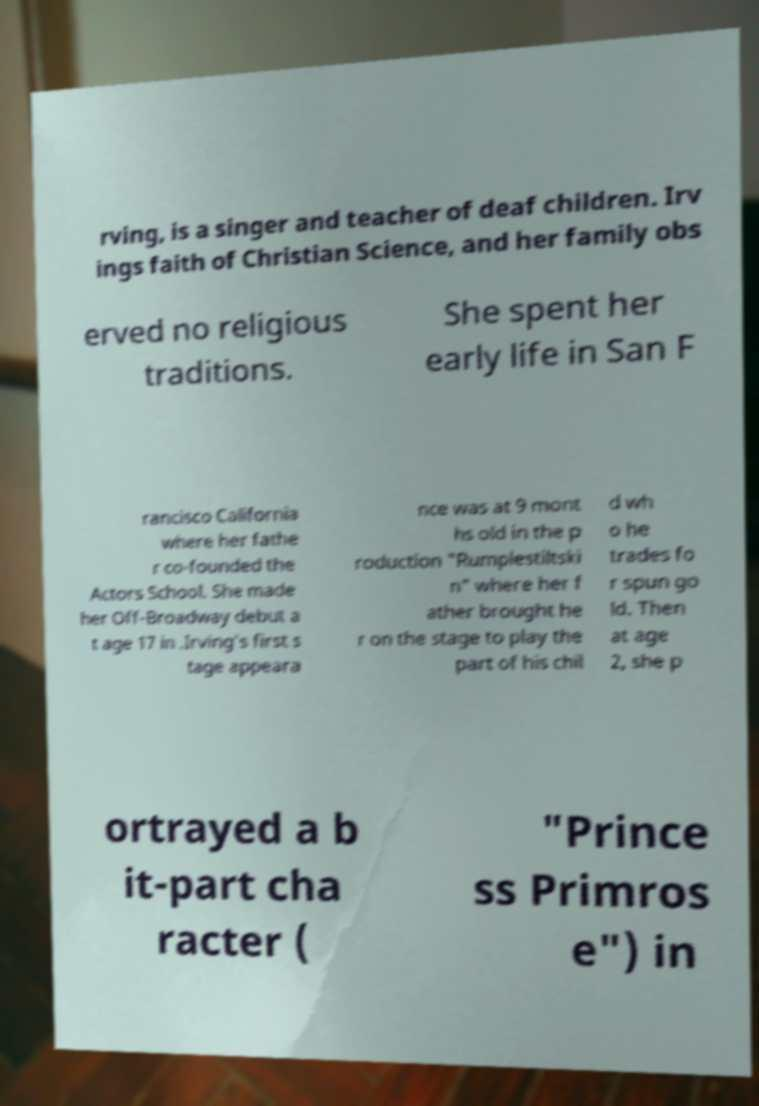Could you extract and type out the text from this image? rving, is a singer and teacher of deaf children. Irv ings faith of Christian Science, and her family obs erved no religious traditions. She spent her early life in San F rancisco California where her fathe r co-founded the Actors School. She made her Off-Broadway debut a t age 17 in .Irving's first s tage appeara nce was at 9 mont hs old in the p roduction "Rumplestiltski n" where her f ather brought he r on the stage to play the part of his chil d wh o he trades fo r spun go ld. Then at age 2, she p ortrayed a b it-part cha racter ( "Prince ss Primros e") in 